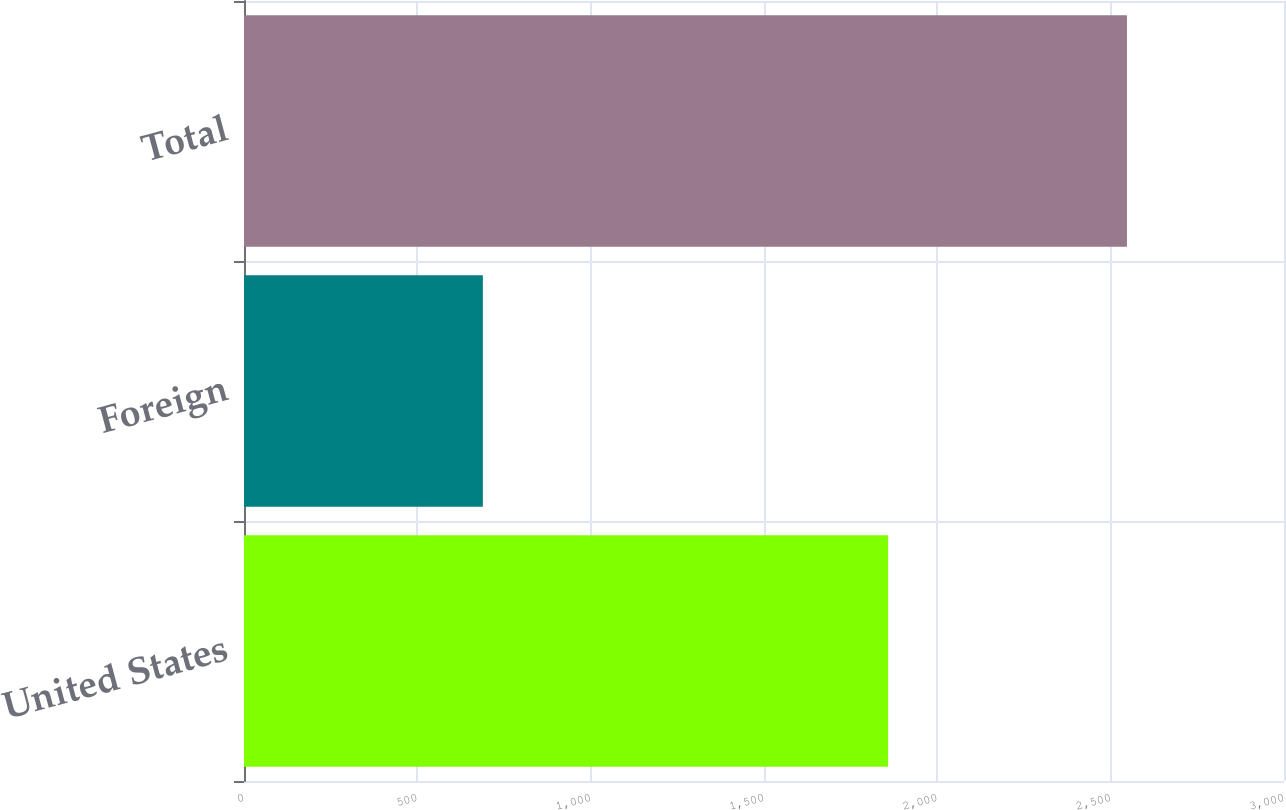<chart> <loc_0><loc_0><loc_500><loc_500><bar_chart><fcel>United States<fcel>Foreign<fcel>Total<nl><fcel>1858<fcel>689<fcel>2547<nl></chart> 